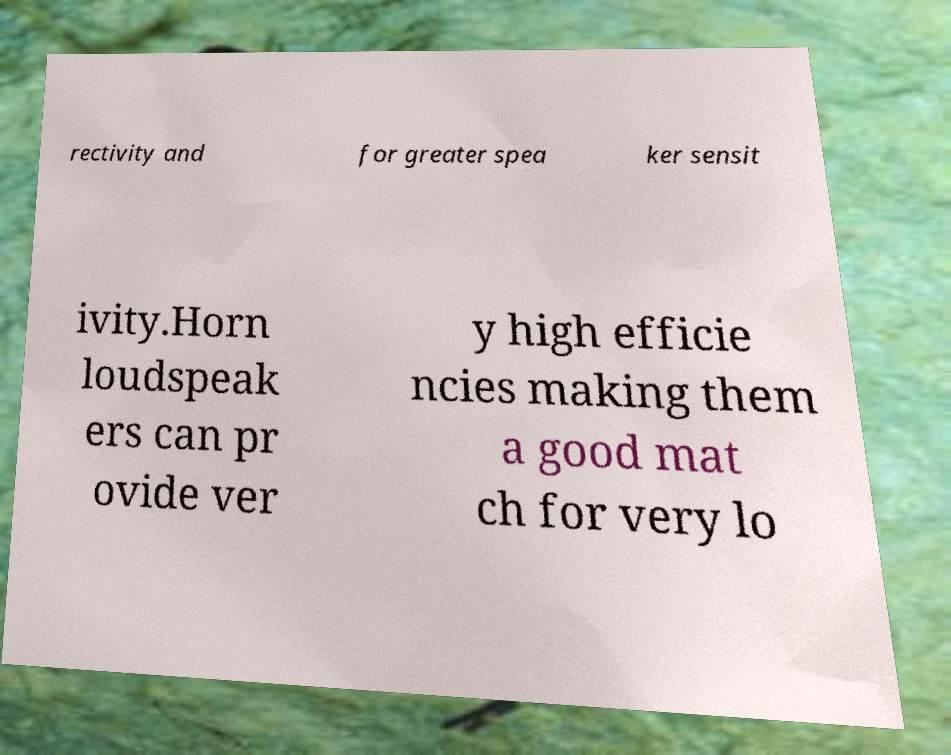Could you extract and type out the text from this image? rectivity and for greater spea ker sensit ivity.Horn loudspeak ers can pr ovide ver y high efficie ncies making them a good mat ch for very lo 